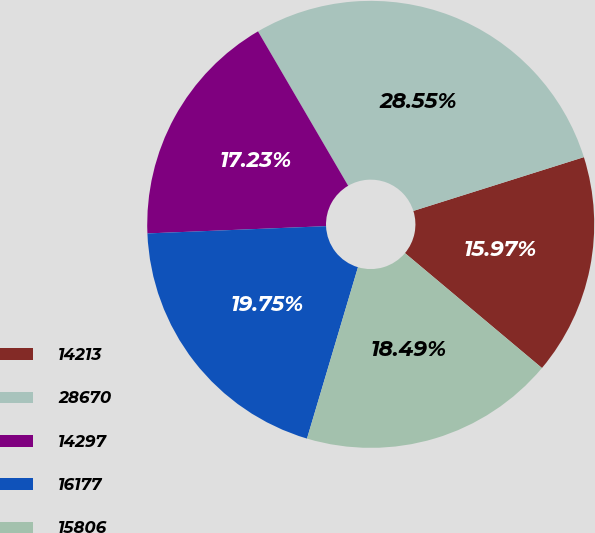<chart> <loc_0><loc_0><loc_500><loc_500><pie_chart><fcel>14213<fcel>28670<fcel>14297<fcel>16177<fcel>15806<nl><fcel>15.97%<fcel>28.55%<fcel>17.23%<fcel>19.75%<fcel>18.49%<nl></chart> 